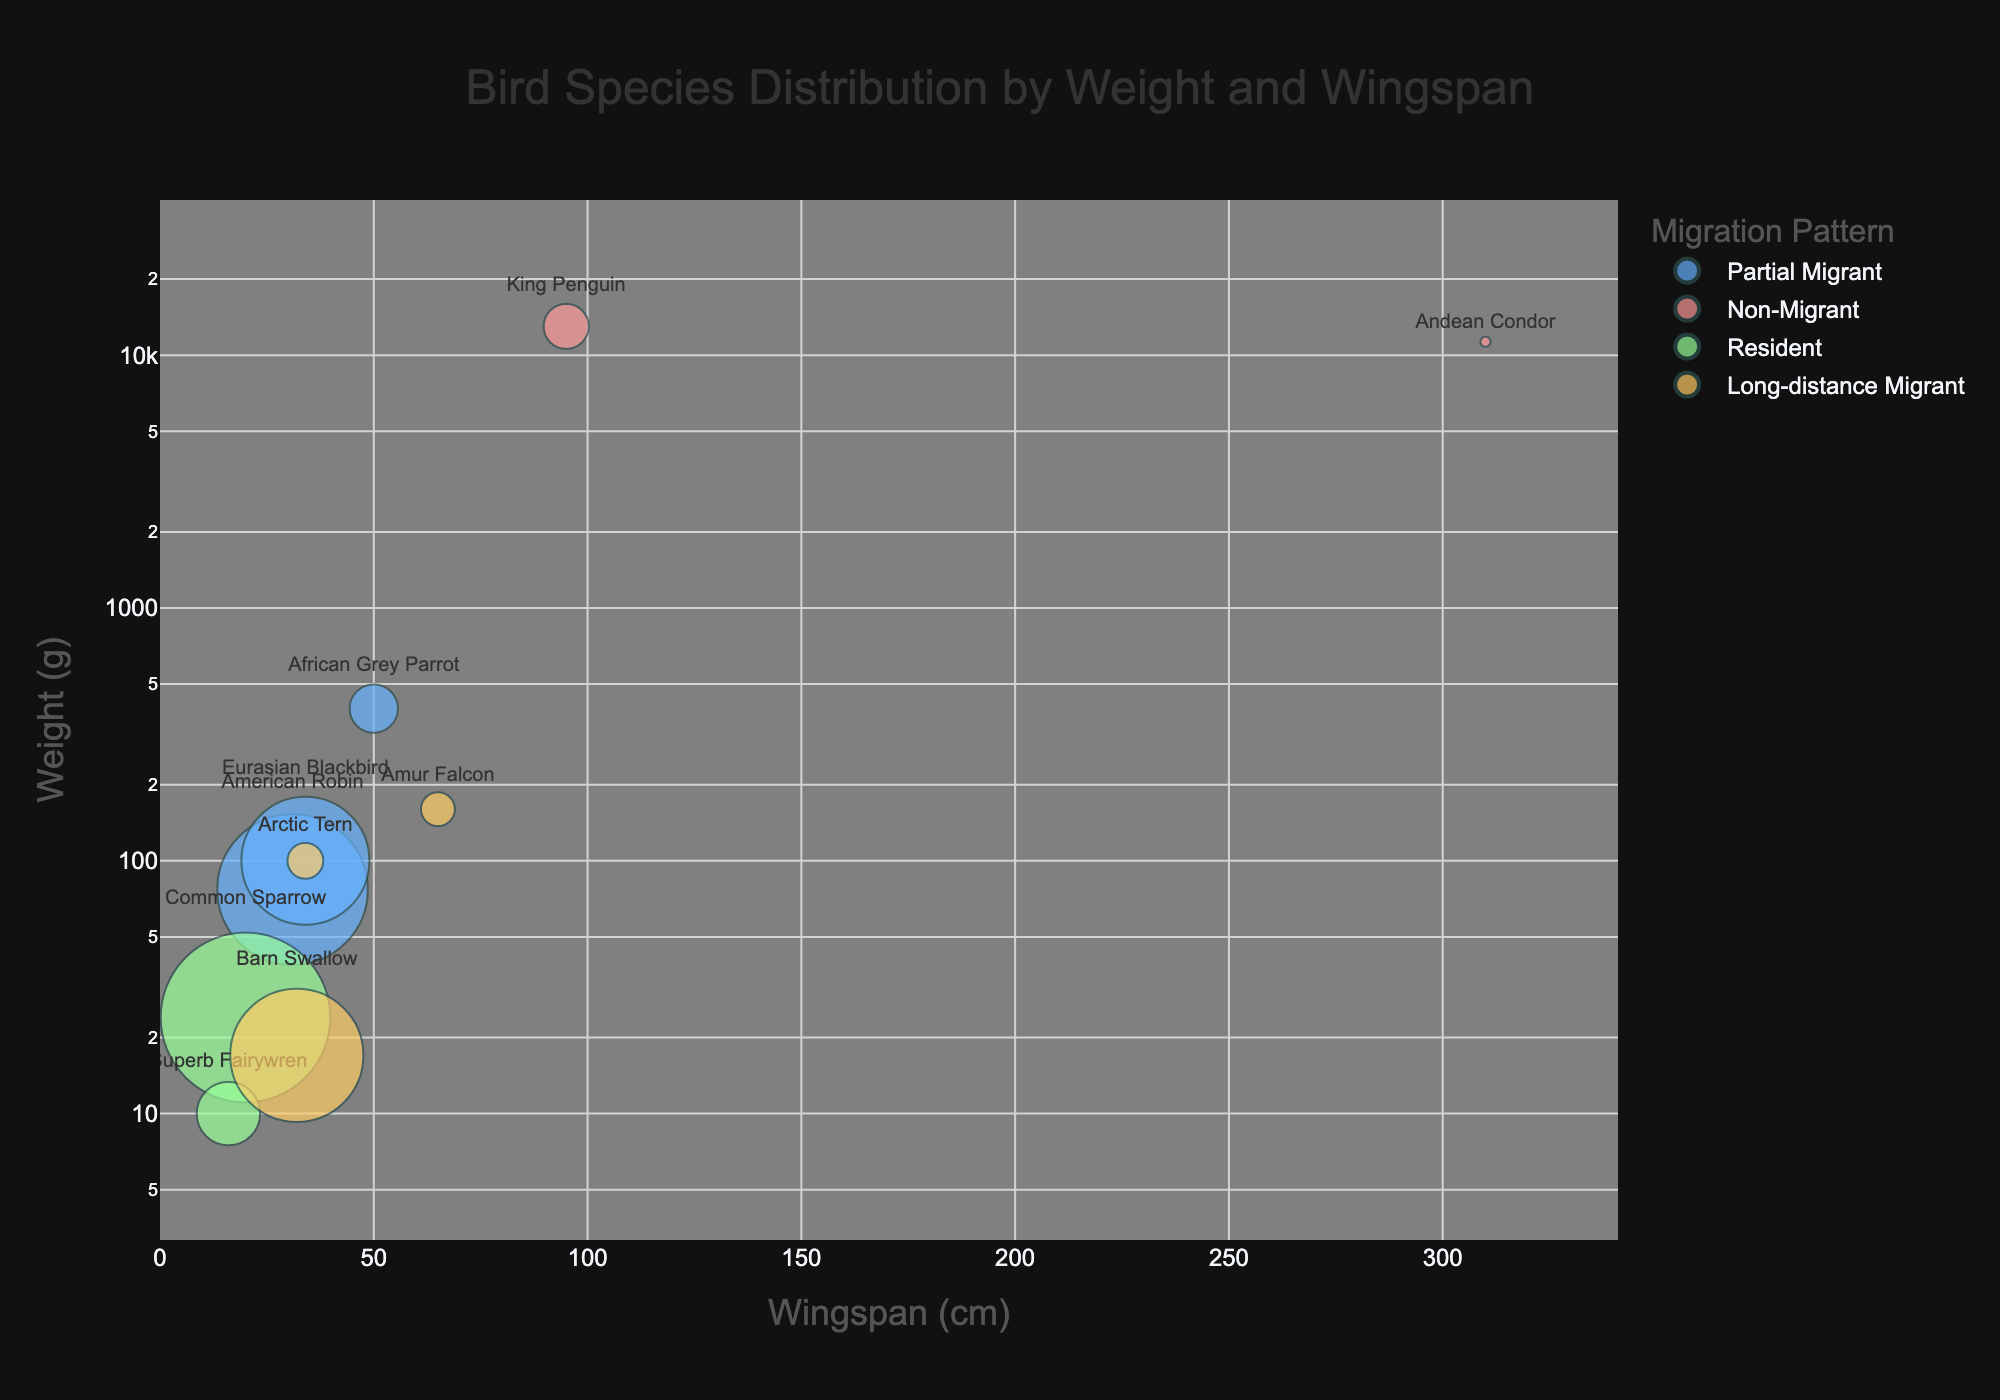What is the title of the bubble chart? The title of the chart is displayed prominently at the top and is clear to read.
Answer: Bird Species Distribution by Weight and Wingspan Which region has the greatest number of bird species listed in the chart? By counting the number of unique bird species names associated with each region, North America has two bird species (American Robin and Arctic Tern), South America has one bird, Europe has two, Africa has two, Asia has two, and Australia has one.
Answer: North America What is the migration pattern of the bird species with the largest population? The largest bubble represents the bird species with the highest population. By hovering over the largest bubble, we see that it corresponds to the Common Sparrow, which has a migration pattern indicated by color, being “Resident”.
Answer: Resident Which bird species has the largest wingspan and what's its wingspan? Identify the point farthest right on the x-axis and read the corresponding wingspan value. The Andean Condor has the largest wingspan at 310 cm.
Answer: Andean Condor, 310 cm Which bird species are residents? Locate the bubbles colored according to the resident migration pattern color, hover over them to identify the species. The Common Sparrow and Superb Fairywren are both residents.
Answer: Common Sparrow, Superb Fairywren How does the weight of the Barn Swallow compare to the weight of the Arctic Tern? Identify the bubbles for Barn Swallow and Arctic Tern and compare their positions on the y-axis. The Barn Swallow has a weight of 17 g while the Arctic Tern weighs 100 g.
Answer: The Barn Swallow is lighter Which bird species with a wingspan of 65 cm has the lowest population? Find the bubble positioned over 65 cm on the x-axis and check the bubble size for the smallest one which is the Amur Falcon.
Answer: Amur Falcon What is the combined population of all long-distance migrant bird species? Identify the bubbles for long-distance migrant birds and sum their populations: Arctic Tern (1,000,000), Amur Falcon (800,000), and Barn Swallow (190,000,000). Their combined population is 191,800,000.
Answer: 191,800,000 Which bird species has the largest average weight and what is its weight? Locate the highest point on the y-axis, and hover over to identify that the King Penguin has the largest average weight at 13,000 g.
Answer: King Penguin, 13,000 g 